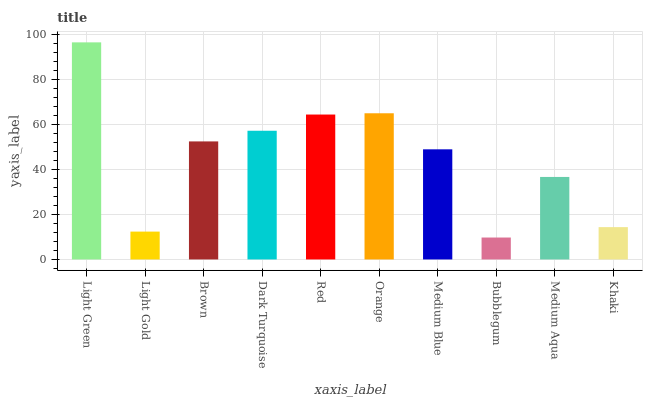Is Bubblegum the minimum?
Answer yes or no. Yes. Is Light Green the maximum?
Answer yes or no. Yes. Is Light Gold the minimum?
Answer yes or no. No. Is Light Gold the maximum?
Answer yes or no. No. Is Light Green greater than Light Gold?
Answer yes or no. Yes. Is Light Gold less than Light Green?
Answer yes or no. Yes. Is Light Gold greater than Light Green?
Answer yes or no. No. Is Light Green less than Light Gold?
Answer yes or no. No. Is Brown the high median?
Answer yes or no. Yes. Is Medium Blue the low median?
Answer yes or no. Yes. Is Light Gold the high median?
Answer yes or no. No. Is Light Gold the low median?
Answer yes or no. No. 